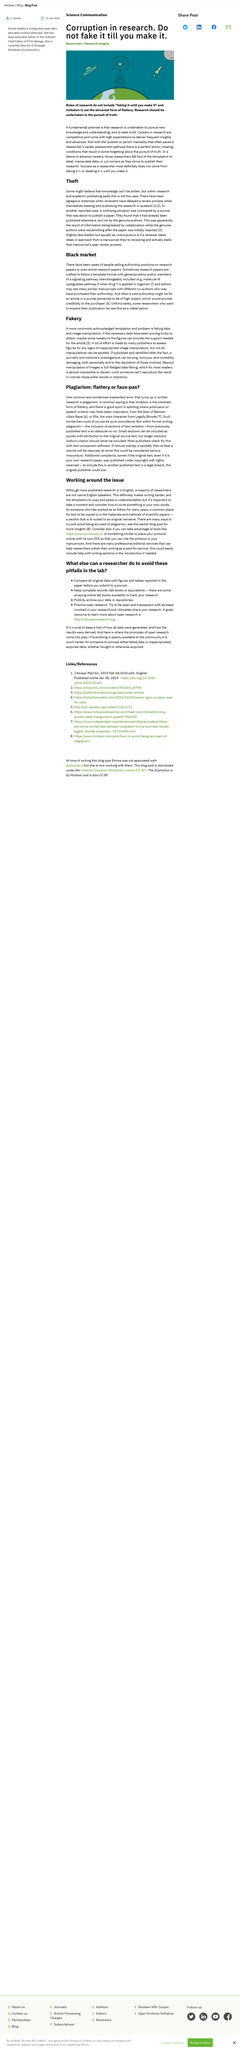Indicate a few pertinent items in this graphic. It is considered theft if a reviewer takes ideas from a manuscript they are reviewing and stalls the manuscript's peer review process. The viable option they see is an article in a journal. A self-published author would have likely sought ownership of the copyright in an article published in a journal. It is almost impossible for readers to discern data faking. It is possible for a reader to detect the presence of data faking by observing implausible results or statistics in a given dataset. 